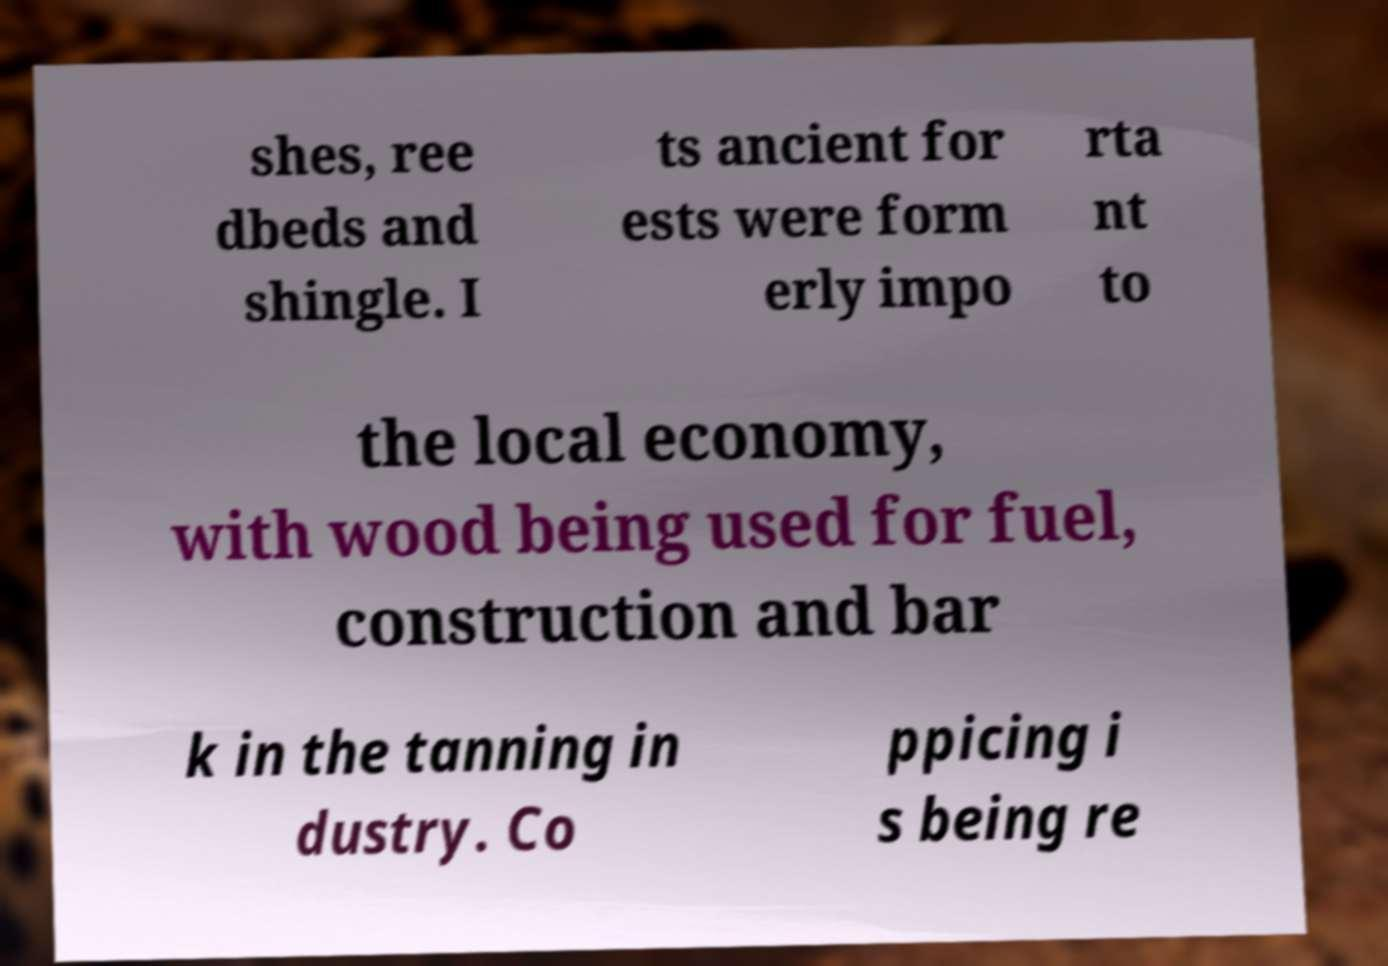Can you accurately transcribe the text from the provided image for me? shes, ree dbeds and shingle. I ts ancient for ests were form erly impo rta nt to the local economy, with wood being used for fuel, construction and bar k in the tanning in dustry. Co ppicing i s being re 